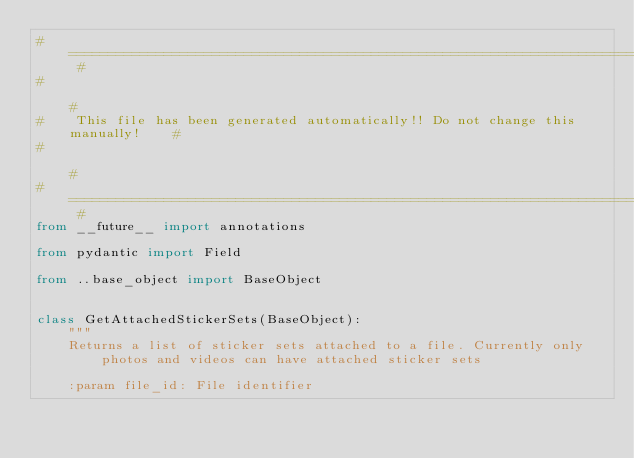Convert code to text. <code><loc_0><loc_0><loc_500><loc_500><_Python_># =============================================================================== #
#                                                                                 #
#    This file has been generated automatically!! Do not change this manually!    #
#                                                                                 #
# =============================================================================== #
from __future__ import annotations

from pydantic import Field

from ..base_object import BaseObject


class GetAttachedStickerSets(BaseObject):
    """
    Returns a list of sticker sets attached to a file. Currently only photos and videos can have attached sticker sets
    
    :param file_id: File identifier</code> 